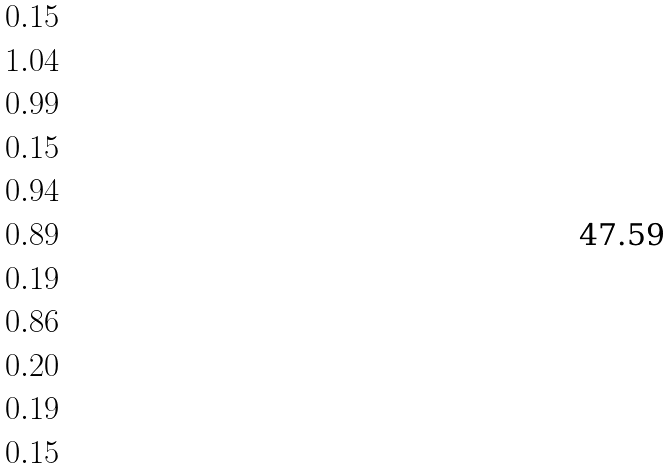Convert formula to latex. <formula><loc_0><loc_0><loc_500><loc_500>\begin{matrix} 0 . 1 5 \\ 1 . 0 4 \\ 0 . 9 9 \\ 0 . 1 5 \\ 0 . 9 4 \\ 0 . 8 9 \\ 0 . 1 9 \\ 0 . 8 6 \\ 0 . 2 0 \\ 0 . 1 9 \\ 0 . 1 5 \\ \end{matrix}</formula> 